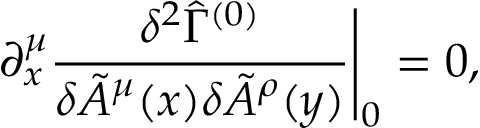<formula> <loc_0><loc_0><loc_500><loc_500>\partial _ { x } ^ { \mu } \frac { \delta ^ { 2 } \hat { \Gamma } ^ { ( 0 ) } } { \delta \tilde { A } ^ { \mu } ( x ) \delta \tilde { A } ^ { \rho } ( y ) } \Big | _ { 0 } = 0 ,</formula> 